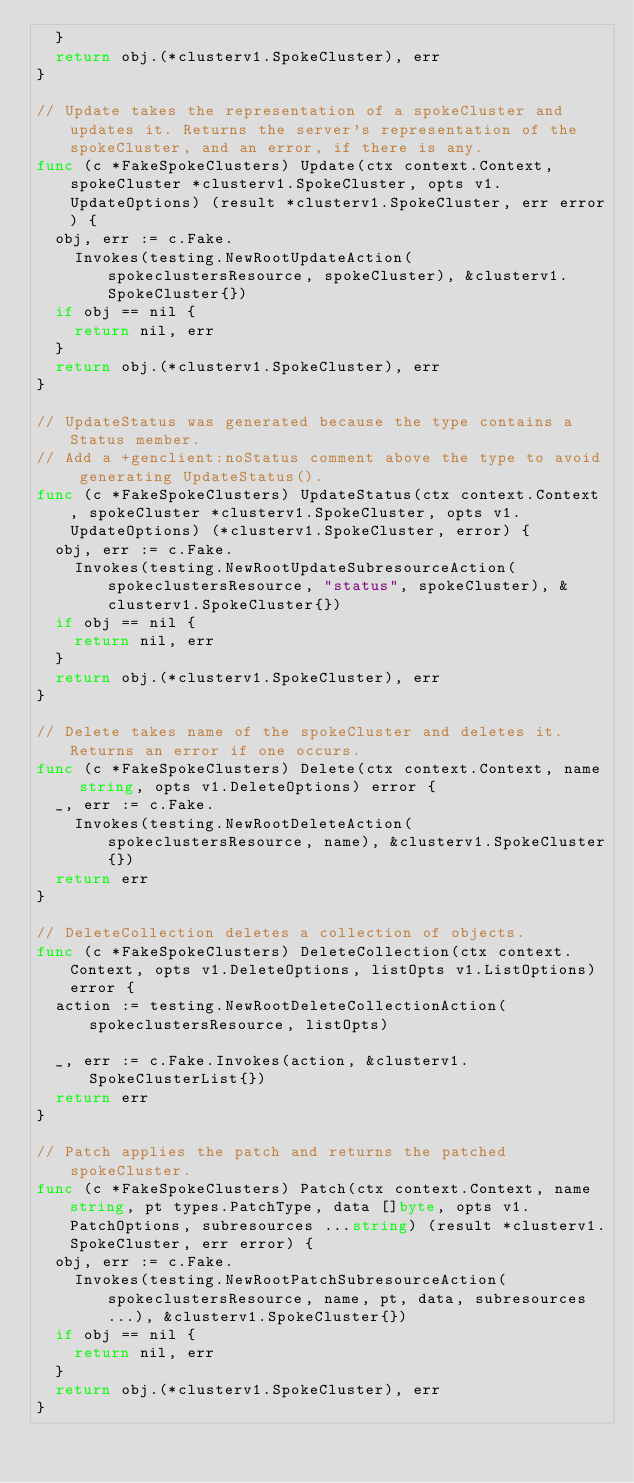Convert code to text. <code><loc_0><loc_0><loc_500><loc_500><_Go_>	}
	return obj.(*clusterv1.SpokeCluster), err
}

// Update takes the representation of a spokeCluster and updates it. Returns the server's representation of the spokeCluster, and an error, if there is any.
func (c *FakeSpokeClusters) Update(ctx context.Context, spokeCluster *clusterv1.SpokeCluster, opts v1.UpdateOptions) (result *clusterv1.SpokeCluster, err error) {
	obj, err := c.Fake.
		Invokes(testing.NewRootUpdateAction(spokeclustersResource, spokeCluster), &clusterv1.SpokeCluster{})
	if obj == nil {
		return nil, err
	}
	return obj.(*clusterv1.SpokeCluster), err
}

// UpdateStatus was generated because the type contains a Status member.
// Add a +genclient:noStatus comment above the type to avoid generating UpdateStatus().
func (c *FakeSpokeClusters) UpdateStatus(ctx context.Context, spokeCluster *clusterv1.SpokeCluster, opts v1.UpdateOptions) (*clusterv1.SpokeCluster, error) {
	obj, err := c.Fake.
		Invokes(testing.NewRootUpdateSubresourceAction(spokeclustersResource, "status", spokeCluster), &clusterv1.SpokeCluster{})
	if obj == nil {
		return nil, err
	}
	return obj.(*clusterv1.SpokeCluster), err
}

// Delete takes name of the spokeCluster and deletes it. Returns an error if one occurs.
func (c *FakeSpokeClusters) Delete(ctx context.Context, name string, opts v1.DeleteOptions) error {
	_, err := c.Fake.
		Invokes(testing.NewRootDeleteAction(spokeclustersResource, name), &clusterv1.SpokeCluster{})
	return err
}

// DeleteCollection deletes a collection of objects.
func (c *FakeSpokeClusters) DeleteCollection(ctx context.Context, opts v1.DeleteOptions, listOpts v1.ListOptions) error {
	action := testing.NewRootDeleteCollectionAction(spokeclustersResource, listOpts)

	_, err := c.Fake.Invokes(action, &clusterv1.SpokeClusterList{})
	return err
}

// Patch applies the patch and returns the patched spokeCluster.
func (c *FakeSpokeClusters) Patch(ctx context.Context, name string, pt types.PatchType, data []byte, opts v1.PatchOptions, subresources ...string) (result *clusterv1.SpokeCluster, err error) {
	obj, err := c.Fake.
		Invokes(testing.NewRootPatchSubresourceAction(spokeclustersResource, name, pt, data, subresources...), &clusterv1.SpokeCluster{})
	if obj == nil {
		return nil, err
	}
	return obj.(*clusterv1.SpokeCluster), err
}
</code> 